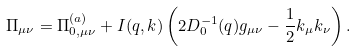<formula> <loc_0><loc_0><loc_500><loc_500>\Pi _ { \mu \nu } = \Pi ^ { ( a ) } _ { 0 , \mu \nu } + I ( q , k ) \left ( 2 D _ { 0 } ^ { - 1 } ( q ) g _ { \mu \nu } - \frac { 1 } { 2 } k _ { \mu } k _ { \nu } \right ) .</formula> 